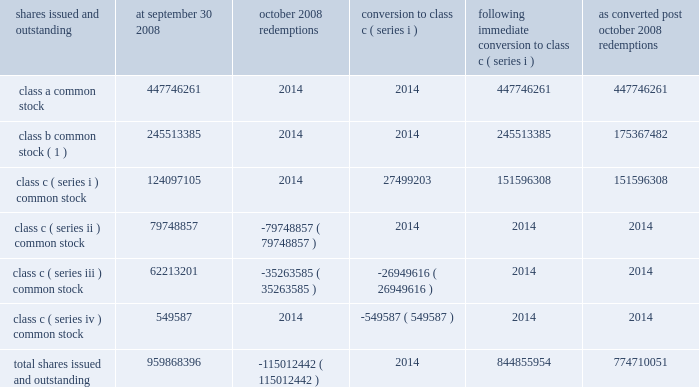Visa inc .
Notes to consolidated financial statements 2014 ( continued ) september 30 , 2008 ( in millions , except as noted ) require the company to redeem all class c ( series ii ) common stock at any time after december 4 , 2008 .
Therefore , in march 2008 , the company reclassified all class c ( series ii ) common stock at its then fair value of $ 1.125 billion to temporary equity on the company 2019s consolidated balance sheet with a corresponding reduction in additional paid-in-capital of $ 1.104 billion and accumulated income ( deficit ) of $ 21 million .
The company accreted this stock to its redemption price of $ 1.146 billion , adjusted for dividends and certain other adjustments , on a straight-line basis , from march 2008 to october 2008 through accumulated income .
See note 4 2014visa europe for a roll-forward of the balance of class c ( series ii ) common stock .
The table sets forth the number of shares of common stock issued and outstanding by class at september 30 , 2008 and the impact of the october 2008 redemptions and subsequent conversion of the remaining outstanding shares of class c ( series iii and series iv ) to class c ( series i ) shares and the number of shares of common stock issued and outstanding after the october 2008 redemptions in total and on as converted basis : shares issued and outstanding september 30 , october 2008 redemptions conversion to class c ( series i ) following immediate conversion to class c ( series i ) converted post october redemptions .
( 1 ) all voting and dividend payment rights are based on the number of shares held multiplied by the applicable conversion rate in effect on the record date , as discussed below .
Subsequent to the ipo and as a result of the initial funding of the litigation escrow account , the conversion rate applicable to class b common stock was approximately 0.71 shares of class a common stock for each share of class b common stock .
Special ipo cash and stock dividends received from cost method investees , net of tax several of the company 2019s cost method investees are also holders of class c ( series i ) common stock and therefore participated in the initial share redemption in march 2008 .
Certain of these investees elected to declare a special cash dividend to return to their owners on a pro rata basis , the proceeds received as a result of the redemption of a portion of their class c ( series i ) common stock .
The dividends represent the return of redemption proceeds .
As a result of the company 2019s ownership interest in these cost method investees , the company received approximately $ 21 million of special dividends from these investees during the third fiscal quarter and recorded a receivable of $ 8 million in prepaid and other assets on its consolidated balance sheet at september 30 , 2008 for a dividend declared by these investees during the fourth fiscal quarter .
In addition , another investee elected to distribute its entire ownership in the company 2019s class c ( series i ) common stock through the distribution of these shares to its investors on a pro rata basis .
As a result , the company received 525443 shares of its own class c ( series i ) common stock during the fourth fiscal quarter and recorded $ 35 million in treasury stock .
The value of the treasury stock was calculated based on sales prices of other recent class c ( series i ) stock transactions by other class c .
What portion of the total shares issued and outstanding are class b common stock? 
Computations: (245513385 / 959868396)
Answer: 0.25578. 